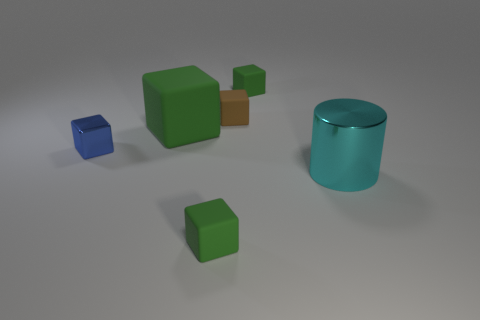The large cyan shiny thing has what shape?
Ensure brevity in your answer.  Cylinder. Does the green block in front of the big cyan shiny object have the same size as the metallic thing that is on the right side of the brown rubber thing?
Provide a short and direct response. No. How big is the metallic thing on the left side of the tiny green matte thing that is behind the small matte cube on the left side of the brown matte block?
Give a very brief answer. Small. What is the shape of the small green rubber object that is in front of the green thing to the left of the tiny green thing that is in front of the cyan shiny object?
Ensure brevity in your answer.  Cube. What shape is the big thing that is in front of the blue metal cube?
Provide a succinct answer. Cylinder. Is the brown block made of the same material as the green block that is in front of the big rubber cube?
Provide a short and direct response. Yes. What number of other objects are the same shape as the big cyan shiny thing?
Offer a terse response. 0. Does the large matte object have the same color as the object that is in front of the cylinder?
Your answer should be compact. Yes. There is a big green matte thing that is to the right of the cube to the left of the large green rubber block; what is its shape?
Your answer should be compact. Cube. There is a small object that is in front of the small blue cube; does it have the same shape as the small blue object?
Your response must be concise. Yes. 